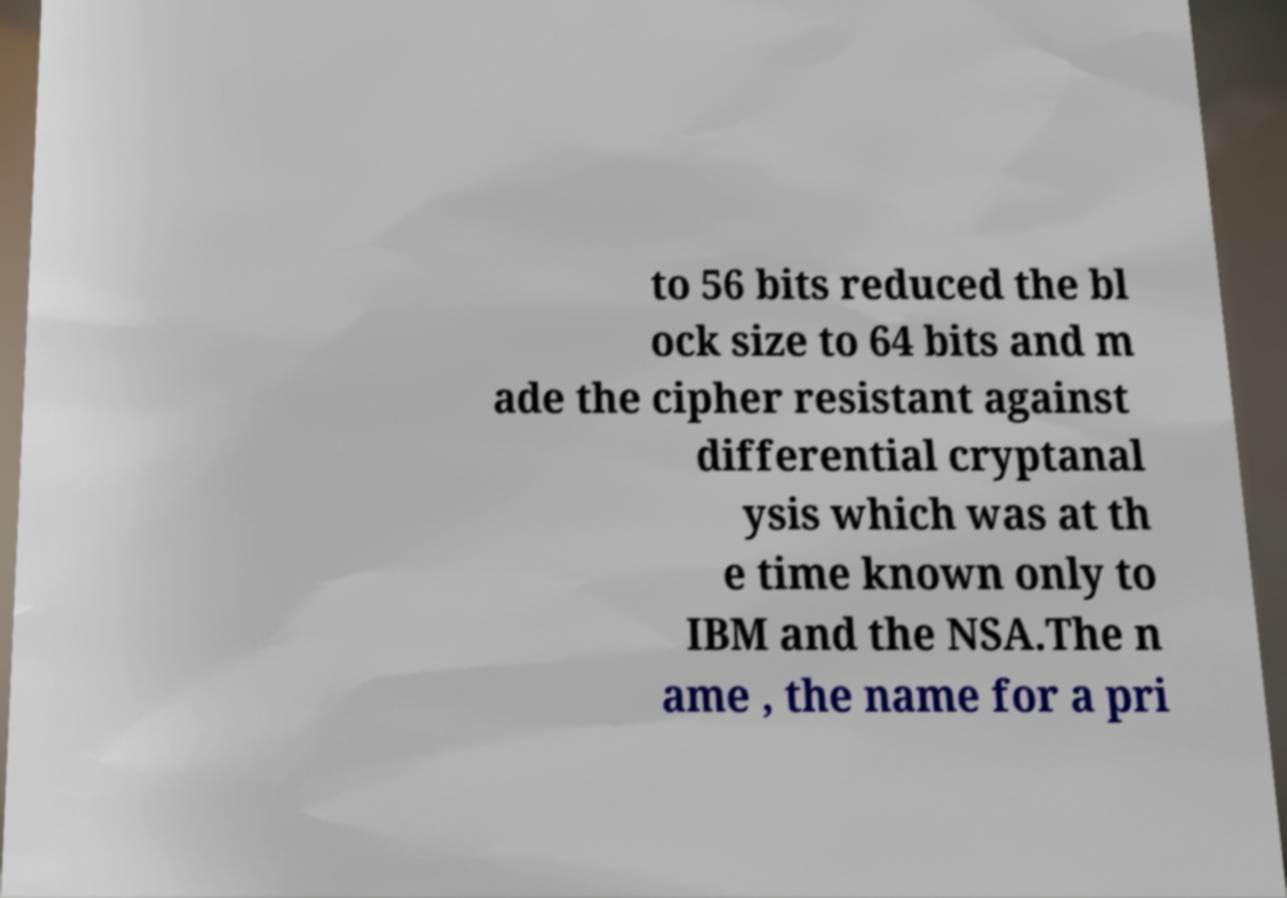Please read and relay the text visible in this image. What does it say? to 56 bits reduced the bl ock size to 64 bits and m ade the cipher resistant against differential cryptanal ysis which was at th e time known only to IBM and the NSA.The n ame , the name for a pri 